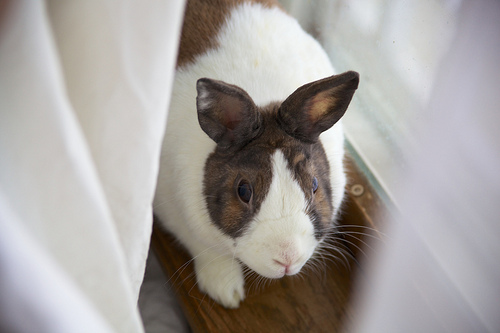<image>
Is there a rabbit in the window? Yes. The rabbit is contained within or inside the window, showing a containment relationship. 